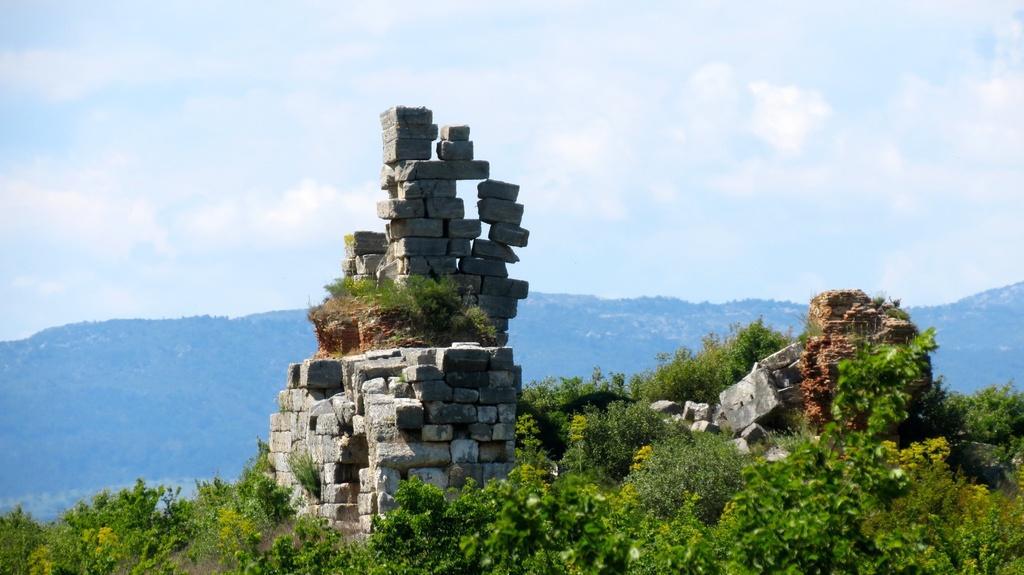In one or two sentences, can you explain what this image depicts? In this picture I can observe stone wall in the middle of the picture. In the bottom of the picture I can observe some plants on the ground. In the background there are hills and some clouds in the sky. 